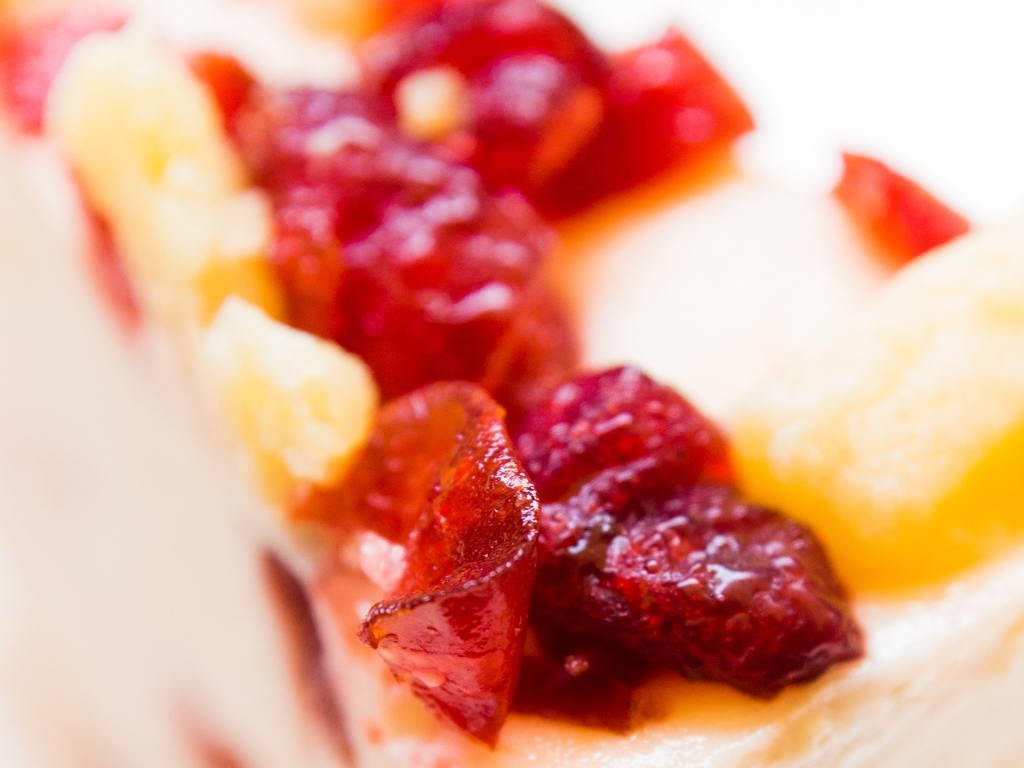This dessert looks quite rich. Can you suggest what occasion it might be best suited for? This luxurious cheesecake with its vibrant fruit toppings would make an exquisite finale to a celebratory meal, be it a birthday, anniversary, or any special gathering where decadent treats are savored. Its opulence and visual appeal also make it a centerpiece-worthy choice for festive events. Could you give me some insights on how the colors of the fruits contribute to the aesthetics of this dessert? Absolutely. The rich reds and bright yellows of the fruits not only introduce a pop of color that is visually arresting but also imply freshness and vibrancy. These contrasting hues against the pale background of the cheesecake enhance its appeal, promising a burst of flavor that is echoed by the enticing appearance. 